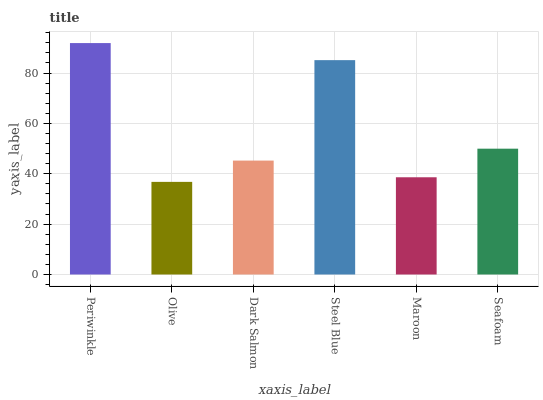Is Olive the minimum?
Answer yes or no. Yes. Is Periwinkle the maximum?
Answer yes or no. Yes. Is Dark Salmon the minimum?
Answer yes or no. No. Is Dark Salmon the maximum?
Answer yes or no. No. Is Dark Salmon greater than Olive?
Answer yes or no. Yes. Is Olive less than Dark Salmon?
Answer yes or no. Yes. Is Olive greater than Dark Salmon?
Answer yes or no. No. Is Dark Salmon less than Olive?
Answer yes or no. No. Is Seafoam the high median?
Answer yes or no. Yes. Is Dark Salmon the low median?
Answer yes or no. Yes. Is Maroon the high median?
Answer yes or no. No. Is Steel Blue the low median?
Answer yes or no. No. 